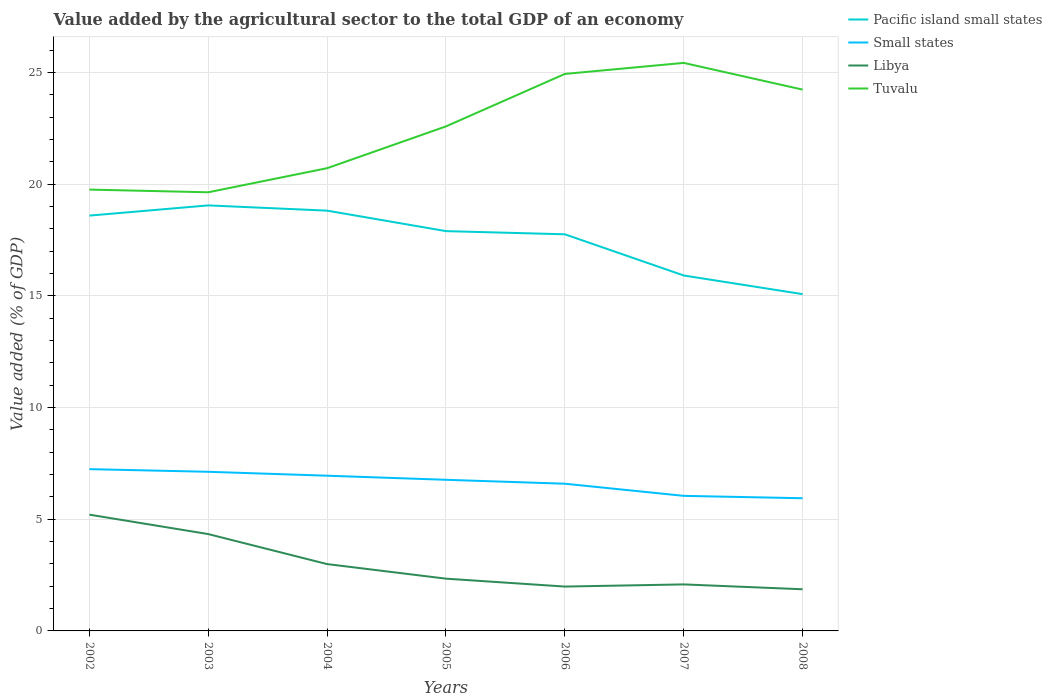Does the line corresponding to Pacific island small states intersect with the line corresponding to Small states?
Provide a short and direct response. No. Across all years, what is the maximum value added by the agricultural sector to the total GDP in Tuvalu?
Ensure brevity in your answer.  19.64. What is the total value added by the agricultural sector to the total GDP in Libya in the graph?
Provide a short and direct response. 1.34. What is the difference between the highest and the second highest value added by the agricultural sector to the total GDP in Pacific island small states?
Your response must be concise. 3.97. How many years are there in the graph?
Your answer should be very brief. 7. What is the difference between two consecutive major ticks on the Y-axis?
Give a very brief answer. 5. Are the values on the major ticks of Y-axis written in scientific E-notation?
Provide a short and direct response. No. Does the graph contain any zero values?
Give a very brief answer. No. Where does the legend appear in the graph?
Offer a terse response. Top right. How many legend labels are there?
Provide a short and direct response. 4. What is the title of the graph?
Ensure brevity in your answer.  Value added by the agricultural sector to the total GDP of an economy. Does "Malaysia" appear as one of the legend labels in the graph?
Your response must be concise. No. What is the label or title of the Y-axis?
Provide a succinct answer. Value added (% of GDP). What is the Value added (% of GDP) in Pacific island small states in 2002?
Your response must be concise. 18.59. What is the Value added (% of GDP) in Small states in 2002?
Give a very brief answer. 7.24. What is the Value added (% of GDP) of Libya in 2002?
Keep it short and to the point. 5.2. What is the Value added (% of GDP) of Tuvalu in 2002?
Your answer should be compact. 19.76. What is the Value added (% of GDP) in Pacific island small states in 2003?
Offer a very short reply. 19.05. What is the Value added (% of GDP) of Small states in 2003?
Provide a succinct answer. 7.12. What is the Value added (% of GDP) in Libya in 2003?
Provide a short and direct response. 4.34. What is the Value added (% of GDP) in Tuvalu in 2003?
Offer a very short reply. 19.64. What is the Value added (% of GDP) of Pacific island small states in 2004?
Your answer should be very brief. 18.82. What is the Value added (% of GDP) in Small states in 2004?
Offer a very short reply. 6.95. What is the Value added (% of GDP) in Libya in 2004?
Make the answer very short. 2.99. What is the Value added (% of GDP) of Tuvalu in 2004?
Ensure brevity in your answer.  20.72. What is the Value added (% of GDP) in Pacific island small states in 2005?
Provide a short and direct response. 17.9. What is the Value added (% of GDP) of Small states in 2005?
Your response must be concise. 6.77. What is the Value added (% of GDP) of Libya in 2005?
Your response must be concise. 2.34. What is the Value added (% of GDP) of Tuvalu in 2005?
Offer a terse response. 22.59. What is the Value added (% of GDP) of Pacific island small states in 2006?
Offer a very short reply. 17.76. What is the Value added (% of GDP) of Small states in 2006?
Give a very brief answer. 6.59. What is the Value added (% of GDP) in Libya in 2006?
Offer a terse response. 1.99. What is the Value added (% of GDP) in Tuvalu in 2006?
Your answer should be compact. 24.94. What is the Value added (% of GDP) in Pacific island small states in 2007?
Offer a very short reply. 15.91. What is the Value added (% of GDP) of Small states in 2007?
Your response must be concise. 6.05. What is the Value added (% of GDP) in Libya in 2007?
Provide a succinct answer. 2.08. What is the Value added (% of GDP) of Tuvalu in 2007?
Provide a short and direct response. 25.43. What is the Value added (% of GDP) in Pacific island small states in 2008?
Offer a very short reply. 15.08. What is the Value added (% of GDP) in Small states in 2008?
Your response must be concise. 5.94. What is the Value added (% of GDP) in Libya in 2008?
Offer a terse response. 1.87. What is the Value added (% of GDP) in Tuvalu in 2008?
Your answer should be compact. 24.23. Across all years, what is the maximum Value added (% of GDP) in Pacific island small states?
Provide a short and direct response. 19.05. Across all years, what is the maximum Value added (% of GDP) of Small states?
Offer a very short reply. 7.24. Across all years, what is the maximum Value added (% of GDP) of Libya?
Your answer should be compact. 5.2. Across all years, what is the maximum Value added (% of GDP) in Tuvalu?
Your answer should be compact. 25.43. Across all years, what is the minimum Value added (% of GDP) of Pacific island small states?
Offer a very short reply. 15.08. Across all years, what is the minimum Value added (% of GDP) of Small states?
Ensure brevity in your answer.  5.94. Across all years, what is the minimum Value added (% of GDP) of Libya?
Your answer should be compact. 1.87. Across all years, what is the minimum Value added (% of GDP) of Tuvalu?
Make the answer very short. 19.64. What is the total Value added (% of GDP) in Pacific island small states in the graph?
Offer a very short reply. 123.1. What is the total Value added (% of GDP) of Small states in the graph?
Your answer should be compact. 46.66. What is the total Value added (% of GDP) of Libya in the graph?
Make the answer very short. 20.81. What is the total Value added (% of GDP) of Tuvalu in the graph?
Ensure brevity in your answer.  157.3. What is the difference between the Value added (% of GDP) in Pacific island small states in 2002 and that in 2003?
Provide a succinct answer. -0.46. What is the difference between the Value added (% of GDP) in Small states in 2002 and that in 2003?
Provide a succinct answer. 0.12. What is the difference between the Value added (% of GDP) in Libya in 2002 and that in 2003?
Make the answer very short. 0.87. What is the difference between the Value added (% of GDP) in Tuvalu in 2002 and that in 2003?
Offer a very short reply. 0.12. What is the difference between the Value added (% of GDP) of Pacific island small states in 2002 and that in 2004?
Your response must be concise. -0.22. What is the difference between the Value added (% of GDP) of Small states in 2002 and that in 2004?
Keep it short and to the point. 0.29. What is the difference between the Value added (% of GDP) in Libya in 2002 and that in 2004?
Your answer should be compact. 2.21. What is the difference between the Value added (% of GDP) in Tuvalu in 2002 and that in 2004?
Your answer should be very brief. -0.96. What is the difference between the Value added (% of GDP) of Pacific island small states in 2002 and that in 2005?
Your response must be concise. 0.69. What is the difference between the Value added (% of GDP) in Small states in 2002 and that in 2005?
Offer a very short reply. 0.48. What is the difference between the Value added (% of GDP) of Libya in 2002 and that in 2005?
Keep it short and to the point. 2.87. What is the difference between the Value added (% of GDP) in Tuvalu in 2002 and that in 2005?
Your response must be concise. -2.83. What is the difference between the Value added (% of GDP) of Pacific island small states in 2002 and that in 2006?
Provide a short and direct response. 0.84. What is the difference between the Value added (% of GDP) of Small states in 2002 and that in 2006?
Provide a succinct answer. 0.65. What is the difference between the Value added (% of GDP) in Libya in 2002 and that in 2006?
Your answer should be very brief. 3.22. What is the difference between the Value added (% of GDP) of Tuvalu in 2002 and that in 2006?
Your answer should be very brief. -5.18. What is the difference between the Value added (% of GDP) of Pacific island small states in 2002 and that in 2007?
Offer a very short reply. 2.68. What is the difference between the Value added (% of GDP) of Small states in 2002 and that in 2007?
Make the answer very short. 1.2. What is the difference between the Value added (% of GDP) of Libya in 2002 and that in 2007?
Provide a short and direct response. 3.12. What is the difference between the Value added (% of GDP) in Tuvalu in 2002 and that in 2007?
Offer a very short reply. -5.67. What is the difference between the Value added (% of GDP) of Pacific island small states in 2002 and that in 2008?
Your response must be concise. 3.52. What is the difference between the Value added (% of GDP) of Small states in 2002 and that in 2008?
Your response must be concise. 1.3. What is the difference between the Value added (% of GDP) in Libya in 2002 and that in 2008?
Offer a very short reply. 3.34. What is the difference between the Value added (% of GDP) of Tuvalu in 2002 and that in 2008?
Give a very brief answer. -4.48. What is the difference between the Value added (% of GDP) in Pacific island small states in 2003 and that in 2004?
Your answer should be compact. 0.23. What is the difference between the Value added (% of GDP) of Small states in 2003 and that in 2004?
Provide a short and direct response. 0.18. What is the difference between the Value added (% of GDP) in Libya in 2003 and that in 2004?
Your response must be concise. 1.34. What is the difference between the Value added (% of GDP) of Tuvalu in 2003 and that in 2004?
Your response must be concise. -1.08. What is the difference between the Value added (% of GDP) in Pacific island small states in 2003 and that in 2005?
Your response must be concise. 1.15. What is the difference between the Value added (% of GDP) of Small states in 2003 and that in 2005?
Your answer should be compact. 0.36. What is the difference between the Value added (% of GDP) in Libya in 2003 and that in 2005?
Your answer should be compact. 2. What is the difference between the Value added (% of GDP) in Tuvalu in 2003 and that in 2005?
Your response must be concise. -2.95. What is the difference between the Value added (% of GDP) of Pacific island small states in 2003 and that in 2006?
Your answer should be very brief. 1.29. What is the difference between the Value added (% of GDP) of Small states in 2003 and that in 2006?
Offer a very short reply. 0.53. What is the difference between the Value added (% of GDP) in Libya in 2003 and that in 2006?
Provide a succinct answer. 2.35. What is the difference between the Value added (% of GDP) of Tuvalu in 2003 and that in 2006?
Your answer should be compact. -5.3. What is the difference between the Value added (% of GDP) of Pacific island small states in 2003 and that in 2007?
Provide a short and direct response. 3.14. What is the difference between the Value added (% of GDP) in Small states in 2003 and that in 2007?
Ensure brevity in your answer.  1.08. What is the difference between the Value added (% of GDP) of Libya in 2003 and that in 2007?
Provide a short and direct response. 2.25. What is the difference between the Value added (% of GDP) in Tuvalu in 2003 and that in 2007?
Your answer should be compact. -5.79. What is the difference between the Value added (% of GDP) in Pacific island small states in 2003 and that in 2008?
Your answer should be very brief. 3.97. What is the difference between the Value added (% of GDP) in Small states in 2003 and that in 2008?
Your response must be concise. 1.18. What is the difference between the Value added (% of GDP) of Libya in 2003 and that in 2008?
Offer a terse response. 2.47. What is the difference between the Value added (% of GDP) in Tuvalu in 2003 and that in 2008?
Your answer should be very brief. -4.6. What is the difference between the Value added (% of GDP) of Pacific island small states in 2004 and that in 2005?
Your answer should be compact. 0.92. What is the difference between the Value added (% of GDP) of Small states in 2004 and that in 2005?
Your response must be concise. 0.18. What is the difference between the Value added (% of GDP) in Libya in 2004 and that in 2005?
Provide a succinct answer. 0.65. What is the difference between the Value added (% of GDP) in Tuvalu in 2004 and that in 2005?
Keep it short and to the point. -1.87. What is the difference between the Value added (% of GDP) in Pacific island small states in 2004 and that in 2006?
Provide a short and direct response. 1.06. What is the difference between the Value added (% of GDP) in Small states in 2004 and that in 2006?
Keep it short and to the point. 0.36. What is the difference between the Value added (% of GDP) of Tuvalu in 2004 and that in 2006?
Make the answer very short. -4.22. What is the difference between the Value added (% of GDP) in Pacific island small states in 2004 and that in 2007?
Your response must be concise. 2.9. What is the difference between the Value added (% of GDP) in Small states in 2004 and that in 2007?
Offer a terse response. 0.9. What is the difference between the Value added (% of GDP) of Libya in 2004 and that in 2007?
Provide a succinct answer. 0.91. What is the difference between the Value added (% of GDP) of Tuvalu in 2004 and that in 2007?
Provide a short and direct response. -4.71. What is the difference between the Value added (% of GDP) of Pacific island small states in 2004 and that in 2008?
Provide a short and direct response. 3.74. What is the difference between the Value added (% of GDP) of Small states in 2004 and that in 2008?
Offer a very short reply. 1.01. What is the difference between the Value added (% of GDP) in Libya in 2004 and that in 2008?
Offer a terse response. 1.13. What is the difference between the Value added (% of GDP) in Tuvalu in 2004 and that in 2008?
Offer a terse response. -3.52. What is the difference between the Value added (% of GDP) in Pacific island small states in 2005 and that in 2006?
Provide a short and direct response. 0.14. What is the difference between the Value added (% of GDP) in Small states in 2005 and that in 2006?
Ensure brevity in your answer.  0.18. What is the difference between the Value added (% of GDP) of Libya in 2005 and that in 2006?
Your answer should be very brief. 0.35. What is the difference between the Value added (% of GDP) of Tuvalu in 2005 and that in 2006?
Your answer should be very brief. -2.35. What is the difference between the Value added (% of GDP) of Pacific island small states in 2005 and that in 2007?
Give a very brief answer. 1.99. What is the difference between the Value added (% of GDP) of Small states in 2005 and that in 2007?
Ensure brevity in your answer.  0.72. What is the difference between the Value added (% of GDP) of Libya in 2005 and that in 2007?
Your response must be concise. 0.26. What is the difference between the Value added (% of GDP) of Tuvalu in 2005 and that in 2007?
Your response must be concise. -2.84. What is the difference between the Value added (% of GDP) of Pacific island small states in 2005 and that in 2008?
Your answer should be compact. 2.82. What is the difference between the Value added (% of GDP) of Small states in 2005 and that in 2008?
Your answer should be compact. 0.83. What is the difference between the Value added (% of GDP) of Libya in 2005 and that in 2008?
Offer a terse response. 0.47. What is the difference between the Value added (% of GDP) in Tuvalu in 2005 and that in 2008?
Keep it short and to the point. -1.65. What is the difference between the Value added (% of GDP) in Pacific island small states in 2006 and that in 2007?
Ensure brevity in your answer.  1.84. What is the difference between the Value added (% of GDP) in Small states in 2006 and that in 2007?
Offer a terse response. 0.54. What is the difference between the Value added (% of GDP) of Libya in 2006 and that in 2007?
Your response must be concise. -0.1. What is the difference between the Value added (% of GDP) of Tuvalu in 2006 and that in 2007?
Offer a terse response. -0.49. What is the difference between the Value added (% of GDP) in Pacific island small states in 2006 and that in 2008?
Your response must be concise. 2.68. What is the difference between the Value added (% of GDP) of Small states in 2006 and that in 2008?
Ensure brevity in your answer.  0.65. What is the difference between the Value added (% of GDP) in Libya in 2006 and that in 2008?
Provide a succinct answer. 0.12. What is the difference between the Value added (% of GDP) of Tuvalu in 2006 and that in 2008?
Your answer should be very brief. 0.7. What is the difference between the Value added (% of GDP) of Pacific island small states in 2007 and that in 2008?
Your answer should be compact. 0.83. What is the difference between the Value added (% of GDP) in Small states in 2007 and that in 2008?
Give a very brief answer. 0.11. What is the difference between the Value added (% of GDP) of Libya in 2007 and that in 2008?
Your answer should be compact. 0.22. What is the difference between the Value added (% of GDP) of Tuvalu in 2007 and that in 2008?
Your answer should be very brief. 1.2. What is the difference between the Value added (% of GDP) in Pacific island small states in 2002 and the Value added (% of GDP) in Small states in 2003?
Provide a short and direct response. 11.47. What is the difference between the Value added (% of GDP) of Pacific island small states in 2002 and the Value added (% of GDP) of Libya in 2003?
Ensure brevity in your answer.  14.26. What is the difference between the Value added (% of GDP) of Pacific island small states in 2002 and the Value added (% of GDP) of Tuvalu in 2003?
Provide a short and direct response. -1.04. What is the difference between the Value added (% of GDP) of Small states in 2002 and the Value added (% of GDP) of Libya in 2003?
Offer a terse response. 2.91. What is the difference between the Value added (% of GDP) of Small states in 2002 and the Value added (% of GDP) of Tuvalu in 2003?
Provide a short and direct response. -12.4. What is the difference between the Value added (% of GDP) of Libya in 2002 and the Value added (% of GDP) of Tuvalu in 2003?
Your answer should be compact. -14.43. What is the difference between the Value added (% of GDP) in Pacific island small states in 2002 and the Value added (% of GDP) in Small states in 2004?
Your answer should be compact. 11.64. What is the difference between the Value added (% of GDP) of Pacific island small states in 2002 and the Value added (% of GDP) of Libya in 2004?
Provide a short and direct response. 15.6. What is the difference between the Value added (% of GDP) of Pacific island small states in 2002 and the Value added (% of GDP) of Tuvalu in 2004?
Provide a short and direct response. -2.12. What is the difference between the Value added (% of GDP) in Small states in 2002 and the Value added (% of GDP) in Libya in 2004?
Give a very brief answer. 4.25. What is the difference between the Value added (% of GDP) in Small states in 2002 and the Value added (% of GDP) in Tuvalu in 2004?
Keep it short and to the point. -13.47. What is the difference between the Value added (% of GDP) of Libya in 2002 and the Value added (% of GDP) of Tuvalu in 2004?
Your answer should be very brief. -15.51. What is the difference between the Value added (% of GDP) in Pacific island small states in 2002 and the Value added (% of GDP) in Small states in 2005?
Your answer should be compact. 11.83. What is the difference between the Value added (% of GDP) in Pacific island small states in 2002 and the Value added (% of GDP) in Libya in 2005?
Your response must be concise. 16.25. What is the difference between the Value added (% of GDP) in Pacific island small states in 2002 and the Value added (% of GDP) in Tuvalu in 2005?
Your response must be concise. -3.99. What is the difference between the Value added (% of GDP) of Small states in 2002 and the Value added (% of GDP) of Libya in 2005?
Keep it short and to the point. 4.9. What is the difference between the Value added (% of GDP) in Small states in 2002 and the Value added (% of GDP) in Tuvalu in 2005?
Make the answer very short. -15.35. What is the difference between the Value added (% of GDP) in Libya in 2002 and the Value added (% of GDP) in Tuvalu in 2005?
Make the answer very short. -17.38. What is the difference between the Value added (% of GDP) in Pacific island small states in 2002 and the Value added (% of GDP) in Small states in 2006?
Your answer should be very brief. 12. What is the difference between the Value added (% of GDP) in Pacific island small states in 2002 and the Value added (% of GDP) in Libya in 2006?
Your response must be concise. 16.61. What is the difference between the Value added (% of GDP) in Pacific island small states in 2002 and the Value added (% of GDP) in Tuvalu in 2006?
Your answer should be compact. -6.34. What is the difference between the Value added (% of GDP) in Small states in 2002 and the Value added (% of GDP) in Libya in 2006?
Ensure brevity in your answer.  5.26. What is the difference between the Value added (% of GDP) in Small states in 2002 and the Value added (% of GDP) in Tuvalu in 2006?
Offer a very short reply. -17.69. What is the difference between the Value added (% of GDP) of Libya in 2002 and the Value added (% of GDP) of Tuvalu in 2006?
Provide a short and direct response. -19.73. What is the difference between the Value added (% of GDP) of Pacific island small states in 2002 and the Value added (% of GDP) of Small states in 2007?
Your response must be concise. 12.55. What is the difference between the Value added (% of GDP) in Pacific island small states in 2002 and the Value added (% of GDP) in Libya in 2007?
Your answer should be compact. 16.51. What is the difference between the Value added (% of GDP) in Pacific island small states in 2002 and the Value added (% of GDP) in Tuvalu in 2007?
Provide a succinct answer. -6.84. What is the difference between the Value added (% of GDP) of Small states in 2002 and the Value added (% of GDP) of Libya in 2007?
Give a very brief answer. 5.16. What is the difference between the Value added (% of GDP) of Small states in 2002 and the Value added (% of GDP) of Tuvalu in 2007?
Make the answer very short. -18.19. What is the difference between the Value added (% of GDP) in Libya in 2002 and the Value added (% of GDP) in Tuvalu in 2007?
Make the answer very short. -20.23. What is the difference between the Value added (% of GDP) of Pacific island small states in 2002 and the Value added (% of GDP) of Small states in 2008?
Your response must be concise. 12.65. What is the difference between the Value added (% of GDP) of Pacific island small states in 2002 and the Value added (% of GDP) of Libya in 2008?
Keep it short and to the point. 16.73. What is the difference between the Value added (% of GDP) of Pacific island small states in 2002 and the Value added (% of GDP) of Tuvalu in 2008?
Offer a very short reply. -5.64. What is the difference between the Value added (% of GDP) in Small states in 2002 and the Value added (% of GDP) in Libya in 2008?
Ensure brevity in your answer.  5.38. What is the difference between the Value added (% of GDP) of Small states in 2002 and the Value added (% of GDP) of Tuvalu in 2008?
Offer a terse response. -16.99. What is the difference between the Value added (% of GDP) in Libya in 2002 and the Value added (% of GDP) in Tuvalu in 2008?
Offer a terse response. -19.03. What is the difference between the Value added (% of GDP) of Pacific island small states in 2003 and the Value added (% of GDP) of Small states in 2004?
Make the answer very short. 12.1. What is the difference between the Value added (% of GDP) of Pacific island small states in 2003 and the Value added (% of GDP) of Libya in 2004?
Keep it short and to the point. 16.06. What is the difference between the Value added (% of GDP) in Pacific island small states in 2003 and the Value added (% of GDP) in Tuvalu in 2004?
Give a very brief answer. -1.67. What is the difference between the Value added (% of GDP) in Small states in 2003 and the Value added (% of GDP) in Libya in 2004?
Keep it short and to the point. 4.13. What is the difference between the Value added (% of GDP) in Small states in 2003 and the Value added (% of GDP) in Tuvalu in 2004?
Offer a terse response. -13.59. What is the difference between the Value added (% of GDP) of Libya in 2003 and the Value added (% of GDP) of Tuvalu in 2004?
Give a very brief answer. -16.38. What is the difference between the Value added (% of GDP) of Pacific island small states in 2003 and the Value added (% of GDP) of Small states in 2005?
Make the answer very short. 12.28. What is the difference between the Value added (% of GDP) in Pacific island small states in 2003 and the Value added (% of GDP) in Libya in 2005?
Make the answer very short. 16.71. What is the difference between the Value added (% of GDP) of Pacific island small states in 2003 and the Value added (% of GDP) of Tuvalu in 2005?
Ensure brevity in your answer.  -3.54. What is the difference between the Value added (% of GDP) of Small states in 2003 and the Value added (% of GDP) of Libya in 2005?
Your answer should be very brief. 4.78. What is the difference between the Value added (% of GDP) in Small states in 2003 and the Value added (% of GDP) in Tuvalu in 2005?
Your answer should be very brief. -15.46. What is the difference between the Value added (% of GDP) in Libya in 2003 and the Value added (% of GDP) in Tuvalu in 2005?
Provide a short and direct response. -18.25. What is the difference between the Value added (% of GDP) of Pacific island small states in 2003 and the Value added (% of GDP) of Small states in 2006?
Your response must be concise. 12.46. What is the difference between the Value added (% of GDP) of Pacific island small states in 2003 and the Value added (% of GDP) of Libya in 2006?
Ensure brevity in your answer.  17.06. What is the difference between the Value added (% of GDP) of Pacific island small states in 2003 and the Value added (% of GDP) of Tuvalu in 2006?
Offer a very short reply. -5.89. What is the difference between the Value added (% of GDP) in Small states in 2003 and the Value added (% of GDP) in Libya in 2006?
Provide a short and direct response. 5.14. What is the difference between the Value added (% of GDP) in Small states in 2003 and the Value added (% of GDP) in Tuvalu in 2006?
Your response must be concise. -17.81. What is the difference between the Value added (% of GDP) of Libya in 2003 and the Value added (% of GDP) of Tuvalu in 2006?
Your answer should be very brief. -20.6. What is the difference between the Value added (% of GDP) in Pacific island small states in 2003 and the Value added (% of GDP) in Small states in 2007?
Offer a very short reply. 13. What is the difference between the Value added (% of GDP) in Pacific island small states in 2003 and the Value added (% of GDP) in Libya in 2007?
Provide a succinct answer. 16.97. What is the difference between the Value added (% of GDP) in Pacific island small states in 2003 and the Value added (% of GDP) in Tuvalu in 2007?
Your answer should be very brief. -6.38. What is the difference between the Value added (% of GDP) of Small states in 2003 and the Value added (% of GDP) of Libya in 2007?
Ensure brevity in your answer.  5.04. What is the difference between the Value added (% of GDP) of Small states in 2003 and the Value added (% of GDP) of Tuvalu in 2007?
Your answer should be compact. -18.31. What is the difference between the Value added (% of GDP) in Libya in 2003 and the Value added (% of GDP) in Tuvalu in 2007?
Make the answer very short. -21.09. What is the difference between the Value added (% of GDP) in Pacific island small states in 2003 and the Value added (% of GDP) in Small states in 2008?
Ensure brevity in your answer.  13.11. What is the difference between the Value added (% of GDP) in Pacific island small states in 2003 and the Value added (% of GDP) in Libya in 2008?
Make the answer very short. 17.19. What is the difference between the Value added (% of GDP) in Pacific island small states in 2003 and the Value added (% of GDP) in Tuvalu in 2008?
Your answer should be compact. -5.18. What is the difference between the Value added (% of GDP) of Small states in 2003 and the Value added (% of GDP) of Libya in 2008?
Your answer should be compact. 5.26. What is the difference between the Value added (% of GDP) of Small states in 2003 and the Value added (% of GDP) of Tuvalu in 2008?
Offer a terse response. -17.11. What is the difference between the Value added (% of GDP) in Libya in 2003 and the Value added (% of GDP) in Tuvalu in 2008?
Offer a very short reply. -19.9. What is the difference between the Value added (% of GDP) in Pacific island small states in 2004 and the Value added (% of GDP) in Small states in 2005?
Your answer should be very brief. 12.05. What is the difference between the Value added (% of GDP) in Pacific island small states in 2004 and the Value added (% of GDP) in Libya in 2005?
Make the answer very short. 16.48. What is the difference between the Value added (% of GDP) in Pacific island small states in 2004 and the Value added (% of GDP) in Tuvalu in 2005?
Give a very brief answer. -3.77. What is the difference between the Value added (% of GDP) of Small states in 2004 and the Value added (% of GDP) of Libya in 2005?
Offer a very short reply. 4.61. What is the difference between the Value added (% of GDP) of Small states in 2004 and the Value added (% of GDP) of Tuvalu in 2005?
Offer a terse response. -15.64. What is the difference between the Value added (% of GDP) of Libya in 2004 and the Value added (% of GDP) of Tuvalu in 2005?
Offer a very short reply. -19.6. What is the difference between the Value added (% of GDP) in Pacific island small states in 2004 and the Value added (% of GDP) in Small states in 2006?
Provide a succinct answer. 12.23. What is the difference between the Value added (% of GDP) in Pacific island small states in 2004 and the Value added (% of GDP) in Libya in 2006?
Keep it short and to the point. 16.83. What is the difference between the Value added (% of GDP) in Pacific island small states in 2004 and the Value added (% of GDP) in Tuvalu in 2006?
Your answer should be compact. -6.12. What is the difference between the Value added (% of GDP) of Small states in 2004 and the Value added (% of GDP) of Libya in 2006?
Your answer should be very brief. 4.96. What is the difference between the Value added (% of GDP) in Small states in 2004 and the Value added (% of GDP) in Tuvalu in 2006?
Your response must be concise. -17.99. What is the difference between the Value added (% of GDP) in Libya in 2004 and the Value added (% of GDP) in Tuvalu in 2006?
Provide a succinct answer. -21.94. What is the difference between the Value added (% of GDP) of Pacific island small states in 2004 and the Value added (% of GDP) of Small states in 2007?
Offer a very short reply. 12.77. What is the difference between the Value added (% of GDP) in Pacific island small states in 2004 and the Value added (% of GDP) in Libya in 2007?
Offer a terse response. 16.73. What is the difference between the Value added (% of GDP) of Pacific island small states in 2004 and the Value added (% of GDP) of Tuvalu in 2007?
Keep it short and to the point. -6.61. What is the difference between the Value added (% of GDP) in Small states in 2004 and the Value added (% of GDP) in Libya in 2007?
Make the answer very short. 4.87. What is the difference between the Value added (% of GDP) of Small states in 2004 and the Value added (% of GDP) of Tuvalu in 2007?
Offer a terse response. -18.48. What is the difference between the Value added (% of GDP) of Libya in 2004 and the Value added (% of GDP) of Tuvalu in 2007?
Give a very brief answer. -22.44. What is the difference between the Value added (% of GDP) of Pacific island small states in 2004 and the Value added (% of GDP) of Small states in 2008?
Provide a short and direct response. 12.88. What is the difference between the Value added (% of GDP) in Pacific island small states in 2004 and the Value added (% of GDP) in Libya in 2008?
Your response must be concise. 16.95. What is the difference between the Value added (% of GDP) of Pacific island small states in 2004 and the Value added (% of GDP) of Tuvalu in 2008?
Make the answer very short. -5.42. What is the difference between the Value added (% of GDP) in Small states in 2004 and the Value added (% of GDP) in Libya in 2008?
Keep it short and to the point. 5.08. What is the difference between the Value added (% of GDP) in Small states in 2004 and the Value added (% of GDP) in Tuvalu in 2008?
Give a very brief answer. -17.28. What is the difference between the Value added (% of GDP) of Libya in 2004 and the Value added (% of GDP) of Tuvalu in 2008?
Ensure brevity in your answer.  -21.24. What is the difference between the Value added (% of GDP) of Pacific island small states in 2005 and the Value added (% of GDP) of Small states in 2006?
Offer a terse response. 11.31. What is the difference between the Value added (% of GDP) of Pacific island small states in 2005 and the Value added (% of GDP) of Libya in 2006?
Your answer should be compact. 15.91. What is the difference between the Value added (% of GDP) in Pacific island small states in 2005 and the Value added (% of GDP) in Tuvalu in 2006?
Your answer should be very brief. -7.04. What is the difference between the Value added (% of GDP) of Small states in 2005 and the Value added (% of GDP) of Libya in 2006?
Offer a terse response. 4.78. What is the difference between the Value added (% of GDP) in Small states in 2005 and the Value added (% of GDP) in Tuvalu in 2006?
Ensure brevity in your answer.  -18.17. What is the difference between the Value added (% of GDP) of Libya in 2005 and the Value added (% of GDP) of Tuvalu in 2006?
Keep it short and to the point. -22.6. What is the difference between the Value added (% of GDP) of Pacific island small states in 2005 and the Value added (% of GDP) of Small states in 2007?
Keep it short and to the point. 11.85. What is the difference between the Value added (% of GDP) in Pacific island small states in 2005 and the Value added (% of GDP) in Libya in 2007?
Your answer should be compact. 15.82. What is the difference between the Value added (% of GDP) of Pacific island small states in 2005 and the Value added (% of GDP) of Tuvalu in 2007?
Give a very brief answer. -7.53. What is the difference between the Value added (% of GDP) in Small states in 2005 and the Value added (% of GDP) in Libya in 2007?
Your answer should be compact. 4.68. What is the difference between the Value added (% of GDP) in Small states in 2005 and the Value added (% of GDP) in Tuvalu in 2007?
Offer a terse response. -18.66. What is the difference between the Value added (% of GDP) of Libya in 2005 and the Value added (% of GDP) of Tuvalu in 2007?
Ensure brevity in your answer.  -23.09. What is the difference between the Value added (% of GDP) in Pacific island small states in 2005 and the Value added (% of GDP) in Small states in 2008?
Your answer should be very brief. 11.96. What is the difference between the Value added (% of GDP) in Pacific island small states in 2005 and the Value added (% of GDP) in Libya in 2008?
Provide a short and direct response. 16.03. What is the difference between the Value added (% of GDP) of Pacific island small states in 2005 and the Value added (% of GDP) of Tuvalu in 2008?
Make the answer very short. -6.33. What is the difference between the Value added (% of GDP) in Small states in 2005 and the Value added (% of GDP) in Libya in 2008?
Provide a short and direct response. 4.9. What is the difference between the Value added (% of GDP) of Small states in 2005 and the Value added (% of GDP) of Tuvalu in 2008?
Your answer should be very brief. -17.47. What is the difference between the Value added (% of GDP) in Libya in 2005 and the Value added (% of GDP) in Tuvalu in 2008?
Keep it short and to the point. -21.89. What is the difference between the Value added (% of GDP) in Pacific island small states in 2006 and the Value added (% of GDP) in Small states in 2007?
Provide a succinct answer. 11.71. What is the difference between the Value added (% of GDP) of Pacific island small states in 2006 and the Value added (% of GDP) of Libya in 2007?
Your answer should be very brief. 15.67. What is the difference between the Value added (% of GDP) of Pacific island small states in 2006 and the Value added (% of GDP) of Tuvalu in 2007?
Give a very brief answer. -7.67. What is the difference between the Value added (% of GDP) of Small states in 2006 and the Value added (% of GDP) of Libya in 2007?
Offer a terse response. 4.51. What is the difference between the Value added (% of GDP) of Small states in 2006 and the Value added (% of GDP) of Tuvalu in 2007?
Keep it short and to the point. -18.84. What is the difference between the Value added (% of GDP) of Libya in 2006 and the Value added (% of GDP) of Tuvalu in 2007?
Your response must be concise. -23.44. What is the difference between the Value added (% of GDP) of Pacific island small states in 2006 and the Value added (% of GDP) of Small states in 2008?
Your response must be concise. 11.82. What is the difference between the Value added (% of GDP) in Pacific island small states in 2006 and the Value added (% of GDP) in Libya in 2008?
Your answer should be very brief. 15.89. What is the difference between the Value added (% of GDP) in Pacific island small states in 2006 and the Value added (% of GDP) in Tuvalu in 2008?
Your response must be concise. -6.48. What is the difference between the Value added (% of GDP) in Small states in 2006 and the Value added (% of GDP) in Libya in 2008?
Your response must be concise. 4.73. What is the difference between the Value added (% of GDP) in Small states in 2006 and the Value added (% of GDP) in Tuvalu in 2008?
Offer a very short reply. -17.64. What is the difference between the Value added (% of GDP) in Libya in 2006 and the Value added (% of GDP) in Tuvalu in 2008?
Offer a terse response. -22.25. What is the difference between the Value added (% of GDP) in Pacific island small states in 2007 and the Value added (% of GDP) in Small states in 2008?
Provide a short and direct response. 9.97. What is the difference between the Value added (% of GDP) in Pacific island small states in 2007 and the Value added (% of GDP) in Libya in 2008?
Your answer should be very brief. 14.05. What is the difference between the Value added (% of GDP) of Pacific island small states in 2007 and the Value added (% of GDP) of Tuvalu in 2008?
Offer a very short reply. -8.32. What is the difference between the Value added (% of GDP) in Small states in 2007 and the Value added (% of GDP) in Libya in 2008?
Your answer should be very brief. 4.18. What is the difference between the Value added (% of GDP) in Small states in 2007 and the Value added (% of GDP) in Tuvalu in 2008?
Your answer should be compact. -18.19. What is the difference between the Value added (% of GDP) in Libya in 2007 and the Value added (% of GDP) in Tuvalu in 2008?
Provide a short and direct response. -22.15. What is the average Value added (% of GDP) of Pacific island small states per year?
Provide a short and direct response. 17.59. What is the average Value added (% of GDP) of Small states per year?
Keep it short and to the point. 6.67. What is the average Value added (% of GDP) in Libya per year?
Your response must be concise. 2.97. What is the average Value added (% of GDP) in Tuvalu per year?
Offer a very short reply. 22.47. In the year 2002, what is the difference between the Value added (% of GDP) in Pacific island small states and Value added (% of GDP) in Small states?
Keep it short and to the point. 11.35. In the year 2002, what is the difference between the Value added (% of GDP) of Pacific island small states and Value added (% of GDP) of Libya?
Keep it short and to the point. 13.39. In the year 2002, what is the difference between the Value added (% of GDP) of Pacific island small states and Value added (% of GDP) of Tuvalu?
Make the answer very short. -1.16. In the year 2002, what is the difference between the Value added (% of GDP) in Small states and Value added (% of GDP) in Libya?
Your response must be concise. 2.04. In the year 2002, what is the difference between the Value added (% of GDP) of Small states and Value added (% of GDP) of Tuvalu?
Provide a short and direct response. -12.52. In the year 2002, what is the difference between the Value added (% of GDP) in Libya and Value added (% of GDP) in Tuvalu?
Offer a very short reply. -14.55. In the year 2003, what is the difference between the Value added (% of GDP) in Pacific island small states and Value added (% of GDP) in Small states?
Ensure brevity in your answer.  11.93. In the year 2003, what is the difference between the Value added (% of GDP) of Pacific island small states and Value added (% of GDP) of Libya?
Your answer should be compact. 14.71. In the year 2003, what is the difference between the Value added (% of GDP) in Pacific island small states and Value added (% of GDP) in Tuvalu?
Your answer should be very brief. -0.59. In the year 2003, what is the difference between the Value added (% of GDP) of Small states and Value added (% of GDP) of Libya?
Make the answer very short. 2.79. In the year 2003, what is the difference between the Value added (% of GDP) of Small states and Value added (% of GDP) of Tuvalu?
Make the answer very short. -12.51. In the year 2003, what is the difference between the Value added (% of GDP) of Libya and Value added (% of GDP) of Tuvalu?
Offer a terse response. -15.3. In the year 2004, what is the difference between the Value added (% of GDP) of Pacific island small states and Value added (% of GDP) of Small states?
Provide a short and direct response. 11.87. In the year 2004, what is the difference between the Value added (% of GDP) of Pacific island small states and Value added (% of GDP) of Libya?
Your answer should be very brief. 15.82. In the year 2004, what is the difference between the Value added (% of GDP) in Pacific island small states and Value added (% of GDP) in Tuvalu?
Ensure brevity in your answer.  -1.9. In the year 2004, what is the difference between the Value added (% of GDP) in Small states and Value added (% of GDP) in Libya?
Give a very brief answer. 3.96. In the year 2004, what is the difference between the Value added (% of GDP) in Small states and Value added (% of GDP) in Tuvalu?
Keep it short and to the point. -13.77. In the year 2004, what is the difference between the Value added (% of GDP) in Libya and Value added (% of GDP) in Tuvalu?
Your answer should be compact. -17.72. In the year 2005, what is the difference between the Value added (% of GDP) in Pacific island small states and Value added (% of GDP) in Small states?
Make the answer very short. 11.13. In the year 2005, what is the difference between the Value added (% of GDP) of Pacific island small states and Value added (% of GDP) of Libya?
Offer a very short reply. 15.56. In the year 2005, what is the difference between the Value added (% of GDP) in Pacific island small states and Value added (% of GDP) in Tuvalu?
Make the answer very short. -4.69. In the year 2005, what is the difference between the Value added (% of GDP) in Small states and Value added (% of GDP) in Libya?
Offer a very short reply. 4.43. In the year 2005, what is the difference between the Value added (% of GDP) in Small states and Value added (% of GDP) in Tuvalu?
Offer a terse response. -15.82. In the year 2005, what is the difference between the Value added (% of GDP) of Libya and Value added (% of GDP) of Tuvalu?
Keep it short and to the point. -20.25. In the year 2006, what is the difference between the Value added (% of GDP) of Pacific island small states and Value added (% of GDP) of Small states?
Ensure brevity in your answer.  11.17. In the year 2006, what is the difference between the Value added (% of GDP) in Pacific island small states and Value added (% of GDP) in Libya?
Keep it short and to the point. 15.77. In the year 2006, what is the difference between the Value added (% of GDP) in Pacific island small states and Value added (% of GDP) in Tuvalu?
Your answer should be very brief. -7.18. In the year 2006, what is the difference between the Value added (% of GDP) in Small states and Value added (% of GDP) in Libya?
Provide a succinct answer. 4.6. In the year 2006, what is the difference between the Value added (% of GDP) in Small states and Value added (% of GDP) in Tuvalu?
Your answer should be very brief. -18.35. In the year 2006, what is the difference between the Value added (% of GDP) of Libya and Value added (% of GDP) of Tuvalu?
Give a very brief answer. -22.95. In the year 2007, what is the difference between the Value added (% of GDP) of Pacific island small states and Value added (% of GDP) of Small states?
Provide a succinct answer. 9.87. In the year 2007, what is the difference between the Value added (% of GDP) in Pacific island small states and Value added (% of GDP) in Libya?
Give a very brief answer. 13.83. In the year 2007, what is the difference between the Value added (% of GDP) of Pacific island small states and Value added (% of GDP) of Tuvalu?
Ensure brevity in your answer.  -9.52. In the year 2007, what is the difference between the Value added (% of GDP) in Small states and Value added (% of GDP) in Libya?
Ensure brevity in your answer.  3.96. In the year 2007, what is the difference between the Value added (% of GDP) of Small states and Value added (% of GDP) of Tuvalu?
Your response must be concise. -19.38. In the year 2007, what is the difference between the Value added (% of GDP) of Libya and Value added (% of GDP) of Tuvalu?
Make the answer very short. -23.35. In the year 2008, what is the difference between the Value added (% of GDP) in Pacific island small states and Value added (% of GDP) in Small states?
Your answer should be compact. 9.14. In the year 2008, what is the difference between the Value added (% of GDP) in Pacific island small states and Value added (% of GDP) in Libya?
Your answer should be very brief. 13.21. In the year 2008, what is the difference between the Value added (% of GDP) in Pacific island small states and Value added (% of GDP) in Tuvalu?
Provide a succinct answer. -9.16. In the year 2008, what is the difference between the Value added (% of GDP) of Small states and Value added (% of GDP) of Libya?
Your answer should be compact. 4.08. In the year 2008, what is the difference between the Value added (% of GDP) of Small states and Value added (% of GDP) of Tuvalu?
Offer a terse response. -18.29. In the year 2008, what is the difference between the Value added (% of GDP) of Libya and Value added (% of GDP) of Tuvalu?
Ensure brevity in your answer.  -22.37. What is the ratio of the Value added (% of GDP) in Pacific island small states in 2002 to that in 2003?
Ensure brevity in your answer.  0.98. What is the ratio of the Value added (% of GDP) of Small states in 2002 to that in 2003?
Keep it short and to the point. 1.02. What is the ratio of the Value added (% of GDP) of Libya in 2002 to that in 2003?
Give a very brief answer. 1.2. What is the ratio of the Value added (% of GDP) in Pacific island small states in 2002 to that in 2004?
Offer a terse response. 0.99. What is the ratio of the Value added (% of GDP) in Small states in 2002 to that in 2004?
Offer a terse response. 1.04. What is the ratio of the Value added (% of GDP) of Libya in 2002 to that in 2004?
Offer a terse response. 1.74. What is the ratio of the Value added (% of GDP) in Tuvalu in 2002 to that in 2004?
Your response must be concise. 0.95. What is the ratio of the Value added (% of GDP) of Pacific island small states in 2002 to that in 2005?
Provide a succinct answer. 1.04. What is the ratio of the Value added (% of GDP) in Small states in 2002 to that in 2005?
Your answer should be very brief. 1.07. What is the ratio of the Value added (% of GDP) in Libya in 2002 to that in 2005?
Provide a short and direct response. 2.23. What is the ratio of the Value added (% of GDP) of Tuvalu in 2002 to that in 2005?
Offer a terse response. 0.87. What is the ratio of the Value added (% of GDP) of Pacific island small states in 2002 to that in 2006?
Your response must be concise. 1.05. What is the ratio of the Value added (% of GDP) of Small states in 2002 to that in 2006?
Provide a short and direct response. 1.1. What is the ratio of the Value added (% of GDP) in Libya in 2002 to that in 2006?
Provide a succinct answer. 2.62. What is the ratio of the Value added (% of GDP) in Tuvalu in 2002 to that in 2006?
Offer a very short reply. 0.79. What is the ratio of the Value added (% of GDP) in Pacific island small states in 2002 to that in 2007?
Give a very brief answer. 1.17. What is the ratio of the Value added (% of GDP) of Small states in 2002 to that in 2007?
Make the answer very short. 1.2. What is the ratio of the Value added (% of GDP) in Libya in 2002 to that in 2007?
Provide a short and direct response. 2.5. What is the ratio of the Value added (% of GDP) in Tuvalu in 2002 to that in 2007?
Make the answer very short. 0.78. What is the ratio of the Value added (% of GDP) of Pacific island small states in 2002 to that in 2008?
Make the answer very short. 1.23. What is the ratio of the Value added (% of GDP) of Small states in 2002 to that in 2008?
Your answer should be very brief. 1.22. What is the ratio of the Value added (% of GDP) in Libya in 2002 to that in 2008?
Provide a short and direct response. 2.79. What is the ratio of the Value added (% of GDP) in Tuvalu in 2002 to that in 2008?
Provide a short and direct response. 0.82. What is the ratio of the Value added (% of GDP) in Pacific island small states in 2003 to that in 2004?
Provide a succinct answer. 1.01. What is the ratio of the Value added (% of GDP) in Small states in 2003 to that in 2004?
Your answer should be compact. 1.03. What is the ratio of the Value added (% of GDP) in Libya in 2003 to that in 2004?
Ensure brevity in your answer.  1.45. What is the ratio of the Value added (% of GDP) in Tuvalu in 2003 to that in 2004?
Make the answer very short. 0.95. What is the ratio of the Value added (% of GDP) of Pacific island small states in 2003 to that in 2005?
Make the answer very short. 1.06. What is the ratio of the Value added (% of GDP) of Small states in 2003 to that in 2005?
Provide a short and direct response. 1.05. What is the ratio of the Value added (% of GDP) in Libya in 2003 to that in 2005?
Your answer should be compact. 1.85. What is the ratio of the Value added (% of GDP) of Tuvalu in 2003 to that in 2005?
Ensure brevity in your answer.  0.87. What is the ratio of the Value added (% of GDP) in Pacific island small states in 2003 to that in 2006?
Provide a succinct answer. 1.07. What is the ratio of the Value added (% of GDP) in Small states in 2003 to that in 2006?
Your answer should be compact. 1.08. What is the ratio of the Value added (% of GDP) in Libya in 2003 to that in 2006?
Make the answer very short. 2.18. What is the ratio of the Value added (% of GDP) of Tuvalu in 2003 to that in 2006?
Your answer should be compact. 0.79. What is the ratio of the Value added (% of GDP) in Pacific island small states in 2003 to that in 2007?
Make the answer very short. 1.2. What is the ratio of the Value added (% of GDP) in Small states in 2003 to that in 2007?
Give a very brief answer. 1.18. What is the ratio of the Value added (% of GDP) in Libya in 2003 to that in 2007?
Make the answer very short. 2.08. What is the ratio of the Value added (% of GDP) of Tuvalu in 2003 to that in 2007?
Provide a succinct answer. 0.77. What is the ratio of the Value added (% of GDP) in Pacific island small states in 2003 to that in 2008?
Offer a very short reply. 1.26. What is the ratio of the Value added (% of GDP) of Small states in 2003 to that in 2008?
Your answer should be very brief. 1.2. What is the ratio of the Value added (% of GDP) of Libya in 2003 to that in 2008?
Offer a terse response. 2.32. What is the ratio of the Value added (% of GDP) of Tuvalu in 2003 to that in 2008?
Offer a terse response. 0.81. What is the ratio of the Value added (% of GDP) of Pacific island small states in 2004 to that in 2005?
Offer a terse response. 1.05. What is the ratio of the Value added (% of GDP) in Libya in 2004 to that in 2005?
Provide a succinct answer. 1.28. What is the ratio of the Value added (% of GDP) in Tuvalu in 2004 to that in 2005?
Make the answer very short. 0.92. What is the ratio of the Value added (% of GDP) of Pacific island small states in 2004 to that in 2006?
Provide a short and direct response. 1.06. What is the ratio of the Value added (% of GDP) of Small states in 2004 to that in 2006?
Your answer should be compact. 1.05. What is the ratio of the Value added (% of GDP) of Libya in 2004 to that in 2006?
Provide a succinct answer. 1.51. What is the ratio of the Value added (% of GDP) in Tuvalu in 2004 to that in 2006?
Your response must be concise. 0.83. What is the ratio of the Value added (% of GDP) of Pacific island small states in 2004 to that in 2007?
Your answer should be compact. 1.18. What is the ratio of the Value added (% of GDP) of Small states in 2004 to that in 2007?
Ensure brevity in your answer.  1.15. What is the ratio of the Value added (% of GDP) in Libya in 2004 to that in 2007?
Give a very brief answer. 1.44. What is the ratio of the Value added (% of GDP) of Tuvalu in 2004 to that in 2007?
Your answer should be compact. 0.81. What is the ratio of the Value added (% of GDP) in Pacific island small states in 2004 to that in 2008?
Your answer should be compact. 1.25. What is the ratio of the Value added (% of GDP) in Small states in 2004 to that in 2008?
Make the answer very short. 1.17. What is the ratio of the Value added (% of GDP) of Libya in 2004 to that in 2008?
Keep it short and to the point. 1.6. What is the ratio of the Value added (% of GDP) of Tuvalu in 2004 to that in 2008?
Make the answer very short. 0.85. What is the ratio of the Value added (% of GDP) in Pacific island small states in 2005 to that in 2006?
Your answer should be very brief. 1.01. What is the ratio of the Value added (% of GDP) of Small states in 2005 to that in 2006?
Ensure brevity in your answer.  1.03. What is the ratio of the Value added (% of GDP) in Libya in 2005 to that in 2006?
Your response must be concise. 1.18. What is the ratio of the Value added (% of GDP) in Tuvalu in 2005 to that in 2006?
Give a very brief answer. 0.91. What is the ratio of the Value added (% of GDP) in Pacific island small states in 2005 to that in 2007?
Offer a very short reply. 1.12. What is the ratio of the Value added (% of GDP) of Small states in 2005 to that in 2007?
Your answer should be compact. 1.12. What is the ratio of the Value added (% of GDP) in Libya in 2005 to that in 2007?
Make the answer very short. 1.12. What is the ratio of the Value added (% of GDP) in Tuvalu in 2005 to that in 2007?
Keep it short and to the point. 0.89. What is the ratio of the Value added (% of GDP) of Pacific island small states in 2005 to that in 2008?
Your answer should be compact. 1.19. What is the ratio of the Value added (% of GDP) in Small states in 2005 to that in 2008?
Offer a very short reply. 1.14. What is the ratio of the Value added (% of GDP) of Libya in 2005 to that in 2008?
Make the answer very short. 1.25. What is the ratio of the Value added (% of GDP) in Tuvalu in 2005 to that in 2008?
Your answer should be very brief. 0.93. What is the ratio of the Value added (% of GDP) of Pacific island small states in 2006 to that in 2007?
Offer a very short reply. 1.12. What is the ratio of the Value added (% of GDP) of Small states in 2006 to that in 2007?
Give a very brief answer. 1.09. What is the ratio of the Value added (% of GDP) in Libya in 2006 to that in 2007?
Your answer should be very brief. 0.95. What is the ratio of the Value added (% of GDP) of Tuvalu in 2006 to that in 2007?
Keep it short and to the point. 0.98. What is the ratio of the Value added (% of GDP) in Pacific island small states in 2006 to that in 2008?
Your answer should be very brief. 1.18. What is the ratio of the Value added (% of GDP) in Small states in 2006 to that in 2008?
Your answer should be compact. 1.11. What is the ratio of the Value added (% of GDP) in Libya in 2006 to that in 2008?
Ensure brevity in your answer.  1.06. What is the ratio of the Value added (% of GDP) of Pacific island small states in 2007 to that in 2008?
Offer a very short reply. 1.06. What is the ratio of the Value added (% of GDP) in Small states in 2007 to that in 2008?
Provide a succinct answer. 1.02. What is the ratio of the Value added (% of GDP) of Libya in 2007 to that in 2008?
Your answer should be very brief. 1.12. What is the ratio of the Value added (% of GDP) in Tuvalu in 2007 to that in 2008?
Offer a very short reply. 1.05. What is the difference between the highest and the second highest Value added (% of GDP) of Pacific island small states?
Offer a terse response. 0.23. What is the difference between the highest and the second highest Value added (% of GDP) of Small states?
Give a very brief answer. 0.12. What is the difference between the highest and the second highest Value added (% of GDP) in Libya?
Your answer should be compact. 0.87. What is the difference between the highest and the second highest Value added (% of GDP) in Tuvalu?
Your response must be concise. 0.49. What is the difference between the highest and the lowest Value added (% of GDP) of Pacific island small states?
Ensure brevity in your answer.  3.97. What is the difference between the highest and the lowest Value added (% of GDP) of Small states?
Ensure brevity in your answer.  1.3. What is the difference between the highest and the lowest Value added (% of GDP) in Libya?
Your response must be concise. 3.34. What is the difference between the highest and the lowest Value added (% of GDP) of Tuvalu?
Make the answer very short. 5.79. 